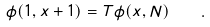<formula> <loc_0><loc_0><loc_500><loc_500>\phi ( 1 , x + 1 ) = T \phi ( x , N ) \quad .</formula> 